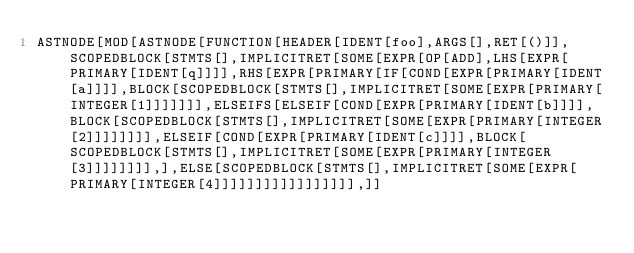Convert code to text. <code><loc_0><loc_0><loc_500><loc_500><_Prolog_>ASTNODE[MOD[ASTNODE[FUNCTION[HEADER[IDENT[foo],ARGS[],RET[()]],SCOPEDBLOCK[STMTS[],IMPLICITRET[SOME[EXPR[OP[ADD],LHS[EXPR[PRIMARY[IDENT[q]]]],RHS[EXPR[PRIMARY[IF[COND[EXPR[PRIMARY[IDENT[a]]]],BLOCK[SCOPEDBLOCK[STMTS[],IMPLICITRET[SOME[EXPR[PRIMARY[INTEGER[1]]]]]]],ELSEIFS[ELSEIF[COND[EXPR[PRIMARY[IDENT[b]]]],BLOCK[SCOPEDBLOCK[STMTS[],IMPLICITRET[SOME[EXPR[PRIMARY[INTEGER[2]]]]]]]],ELSEIF[COND[EXPR[PRIMARY[IDENT[c]]]],BLOCK[SCOPEDBLOCK[STMTS[],IMPLICITRET[SOME[EXPR[PRIMARY[INTEGER[3]]]]]]]],],ELSE[SCOPEDBLOCK[STMTS[],IMPLICITRET[SOME[EXPR[PRIMARY[INTEGER[4]]]]]]]]]]]]]]]]],]]</code> 